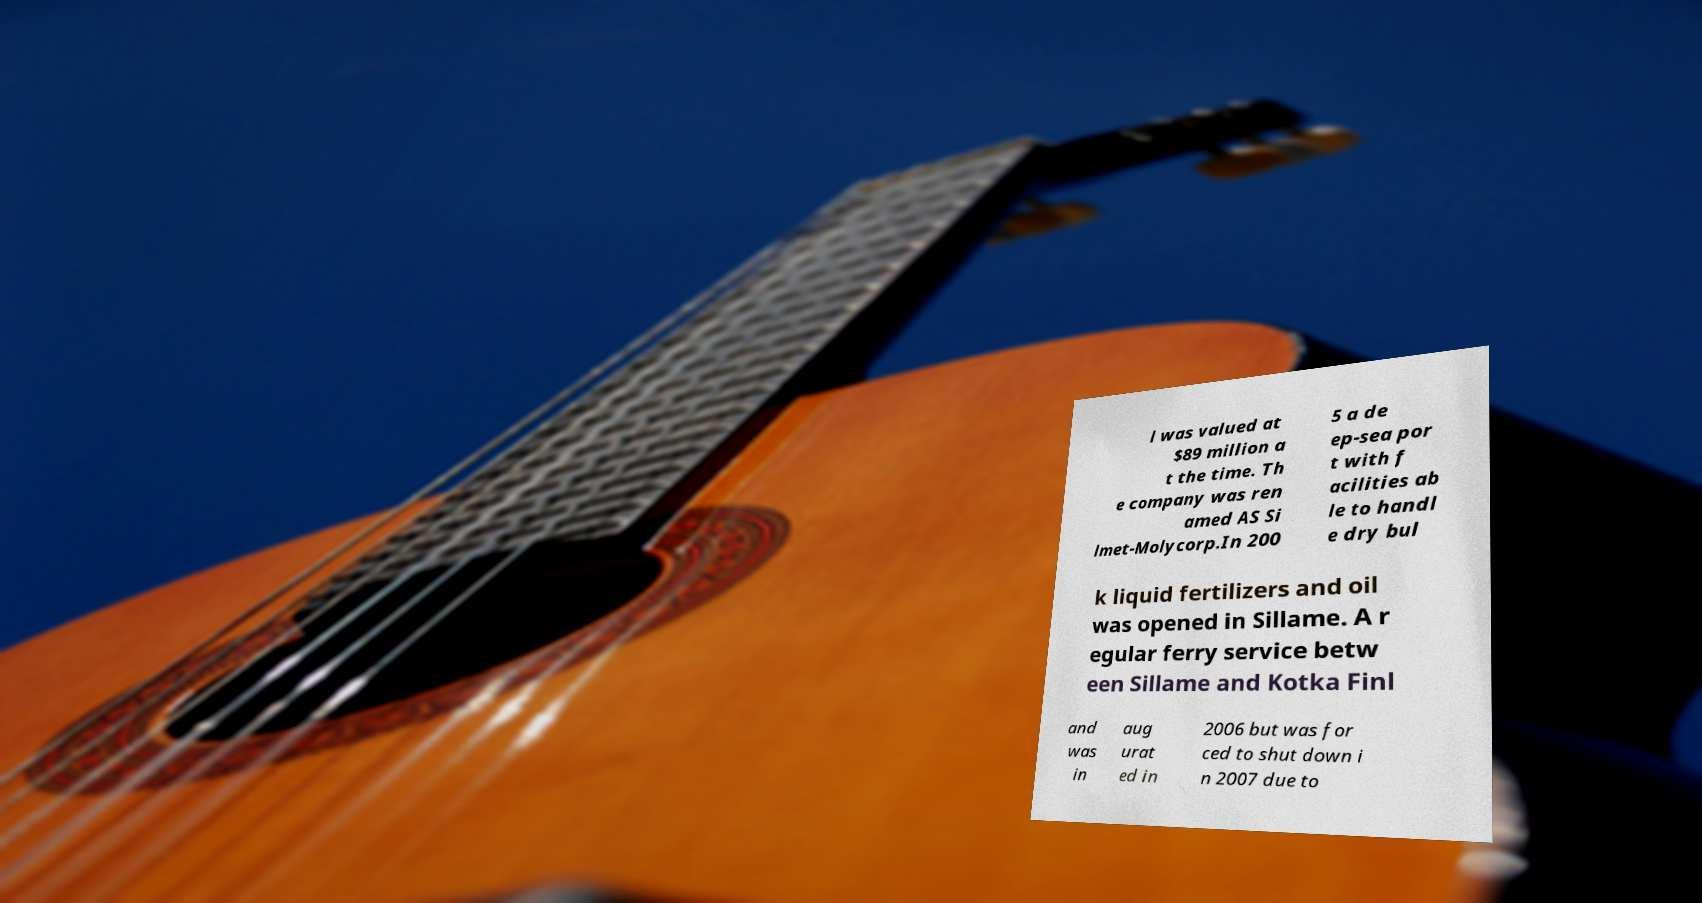Could you assist in decoding the text presented in this image and type it out clearly? l was valued at $89 million a t the time. Th e company was ren amed AS Si lmet-Molycorp.In 200 5 a de ep-sea por t with f acilities ab le to handl e dry bul k liquid fertilizers and oil was opened in Sillame. A r egular ferry service betw een Sillame and Kotka Finl and was in aug urat ed in 2006 but was for ced to shut down i n 2007 due to 